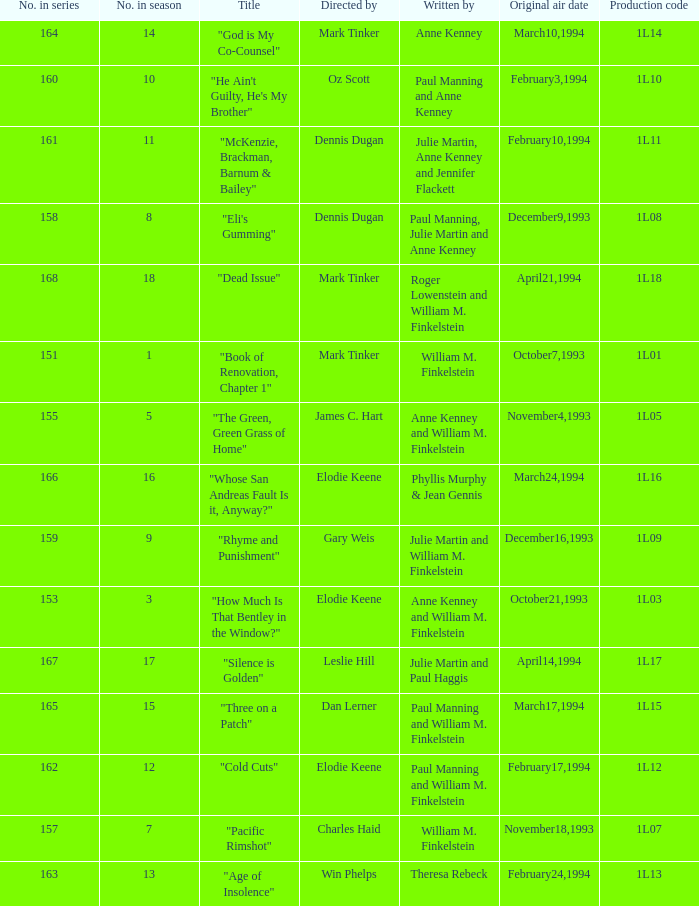Name the original air date for production code 1l16 March24,1994. 